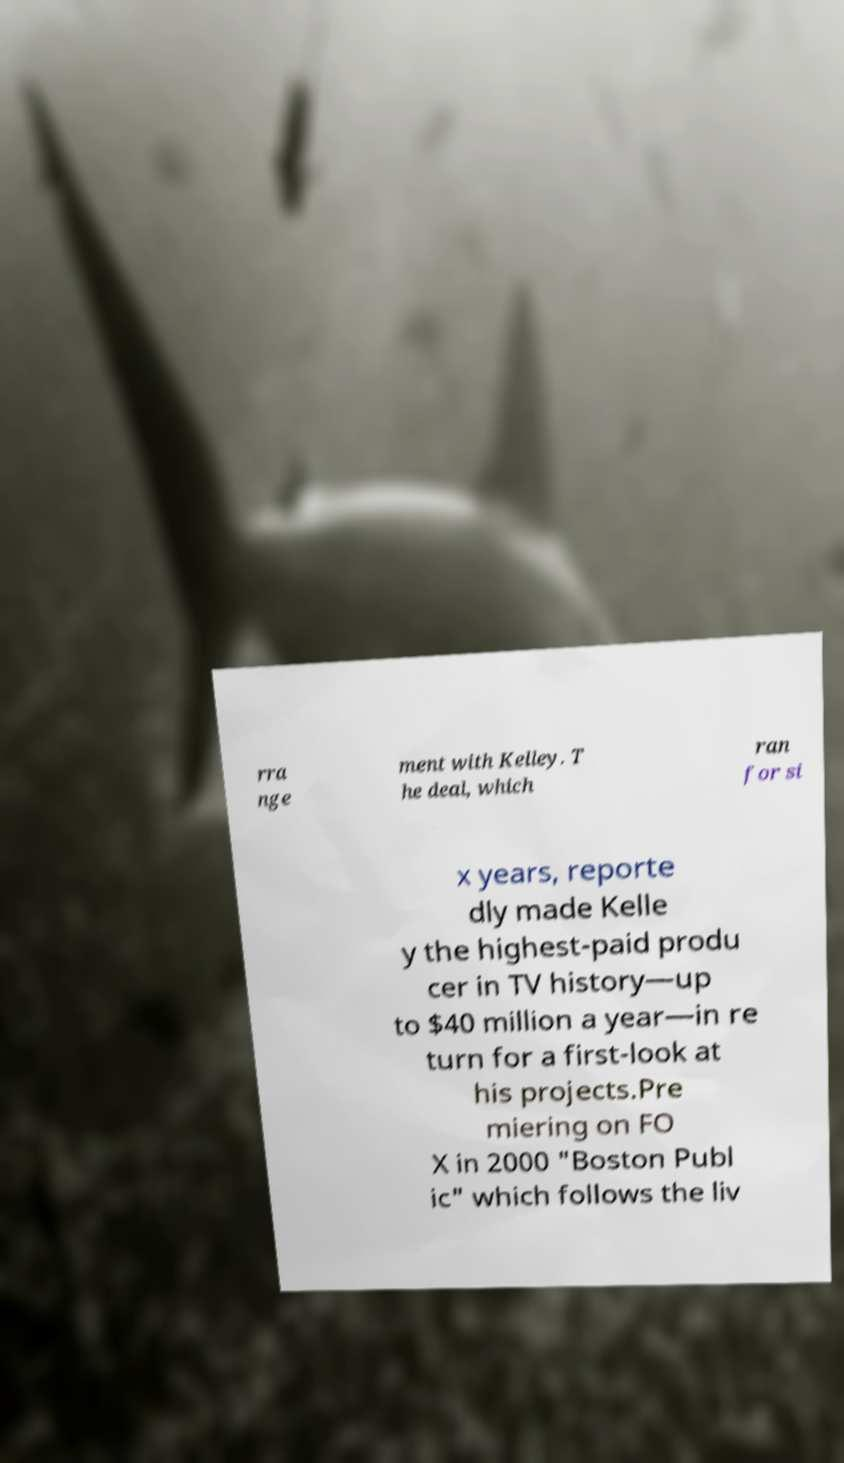What messages or text are displayed in this image? I need them in a readable, typed format. rra nge ment with Kelley. T he deal, which ran for si x years, reporte dly made Kelle y the highest-paid produ cer in TV history—up to $40 million a year—in re turn for a first-look at his projects.Pre miering on FO X in 2000 "Boston Publ ic" which follows the liv 